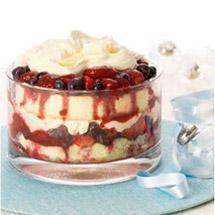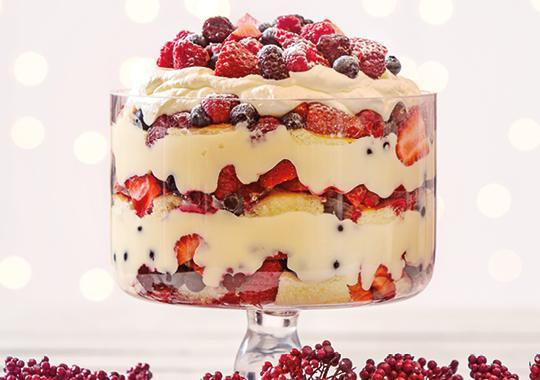The first image is the image on the left, the second image is the image on the right. For the images shown, is this caption "An image shows a dessert garnished with red fruit that features jelly roll slices around the outer edge." true? Answer yes or no. No. The first image is the image on the left, the second image is the image on the right. Considering the images on both sides, is "The cake in the image on the right has several layers." valid? Answer yes or no. Yes. 